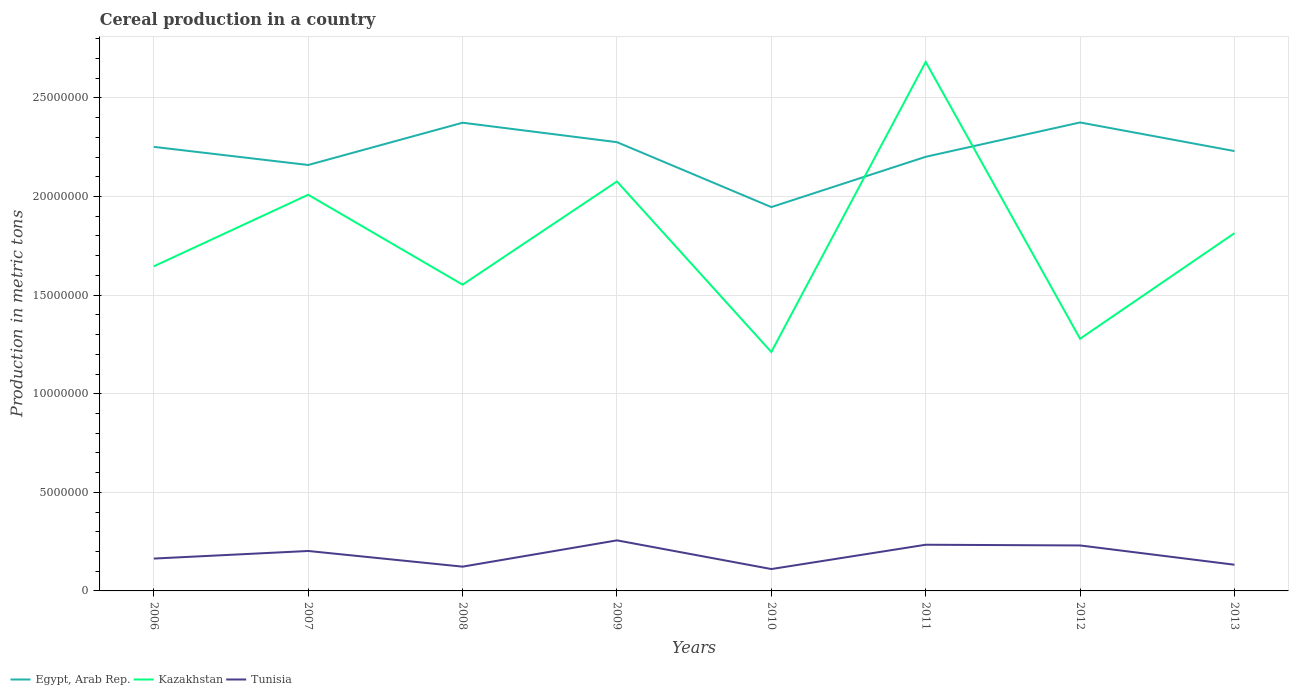Across all years, what is the maximum total cereal production in Egypt, Arab Rep.?
Ensure brevity in your answer.  1.95e+07. What is the total total cereal production in Tunisia in the graph?
Your answer should be very brief. -5.38e+05. What is the difference between the highest and the second highest total cereal production in Kazakhstan?
Offer a very short reply. 1.47e+07. Does the graph contain grids?
Your answer should be very brief. Yes. Where does the legend appear in the graph?
Your answer should be compact. Bottom left. How many legend labels are there?
Offer a terse response. 3. How are the legend labels stacked?
Your answer should be compact. Horizontal. What is the title of the graph?
Keep it short and to the point. Cereal production in a country. Does "Turkey" appear as one of the legend labels in the graph?
Offer a terse response. No. What is the label or title of the Y-axis?
Your answer should be very brief. Production in metric tons. What is the Production in metric tons of Egypt, Arab Rep. in 2006?
Offer a terse response. 2.25e+07. What is the Production in metric tons of Kazakhstan in 2006?
Offer a very short reply. 1.65e+07. What is the Production in metric tons of Tunisia in 2006?
Offer a very short reply. 1.64e+06. What is the Production in metric tons of Egypt, Arab Rep. in 2007?
Provide a short and direct response. 2.16e+07. What is the Production in metric tons in Kazakhstan in 2007?
Make the answer very short. 2.01e+07. What is the Production in metric tons of Tunisia in 2007?
Ensure brevity in your answer.  2.03e+06. What is the Production in metric tons of Egypt, Arab Rep. in 2008?
Your response must be concise. 2.37e+07. What is the Production in metric tons of Kazakhstan in 2008?
Your answer should be very brief. 1.55e+07. What is the Production in metric tons in Tunisia in 2008?
Your answer should be very brief. 1.23e+06. What is the Production in metric tons of Egypt, Arab Rep. in 2009?
Offer a very short reply. 2.28e+07. What is the Production in metric tons in Kazakhstan in 2009?
Ensure brevity in your answer.  2.08e+07. What is the Production in metric tons of Tunisia in 2009?
Make the answer very short. 2.56e+06. What is the Production in metric tons of Egypt, Arab Rep. in 2010?
Keep it short and to the point. 1.95e+07. What is the Production in metric tons of Kazakhstan in 2010?
Keep it short and to the point. 1.21e+07. What is the Production in metric tons of Tunisia in 2010?
Your response must be concise. 1.11e+06. What is the Production in metric tons of Egypt, Arab Rep. in 2011?
Make the answer very short. 2.20e+07. What is the Production in metric tons of Kazakhstan in 2011?
Ensure brevity in your answer.  2.68e+07. What is the Production in metric tons in Tunisia in 2011?
Keep it short and to the point. 2.34e+06. What is the Production in metric tons in Egypt, Arab Rep. in 2012?
Your response must be concise. 2.38e+07. What is the Production in metric tons of Kazakhstan in 2012?
Make the answer very short. 1.28e+07. What is the Production in metric tons in Tunisia in 2012?
Ensure brevity in your answer.  2.31e+06. What is the Production in metric tons in Egypt, Arab Rep. in 2013?
Provide a succinct answer. 2.23e+07. What is the Production in metric tons of Kazakhstan in 2013?
Give a very brief answer. 1.81e+07. What is the Production in metric tons in Tunisia in 2013?
Provide a succinct answer. 1.33e+06. Across all years, what is the maximum Production in metric tons in Egypt, Arab Rep.?
Ensure brevity in your answer.  2.38e+07. Across all years, what is the maximum Production in metric tons of Kazakhstan?
Ensure brevity in your answer.  2.68e+07. Across all years, what is the maximum Production in metric tons in Tunisia?
Make the answer very short. 2.56e+06. Across all years, what is the minimum Production in metric tons in Egypt, Arab Rep.?
Give a very brief answer. 1.95e+07. Across all years, what is the minimum Production in metric tons of Kazakhstan?
Ensure brevity in your answer.  1.21e+07. Across all years, what is the minimum Production in metric tons in Tunisia?
Your answer should be very brief. 1.11e+06. What is the total Production in metric tons of Egypt, Arab Rep. in the graph?
Ensure brevity in your answer.  1.78e+08. What is the total Production in metric tons in Kazakhstan in the graph?
Your answer should be compact. 1.43e+08. What is the total Production in metric tons in Tunisia in the graph?
Your answer should be compact. 1.45e+07. What is the difference between the Production in metric tons in Egypt, Arab Rep. in 2006 and that in 2007?
Ensure brevity in your answer.  9.19e+05. What is the difference between the Production in metric tons of Kazakhstan in 2006 and that in 2007?
Keep it short and to the point. -3.63e+06. What is the difference between the Production in metric tons of Tunisia in 2006 and that in 2007?
Your answer should be compact. -3.85e+05. What is the difference between the Production in metric tons of Egypt, Arab Rep. in 2006 and that in 2008?
Keep it short and to the point. -1.22e+06. What is the difference between the Production in metric tons in Kazakhstan in 2006 and that in 2008?
Your response must be concise. 9.31e+05. What is the difference between the Production in metric tons in Tunisia in 2006 and that in 2008?
Your response must be concise. 4.10e+05. What is the difference between the Production in metric tons in Egypt, Arab Rep. in 2006 and that in 2009?
Your answer should be compact. -2.38e+05. What is the difference between the Production in metric tons of Kazakhstan in 2006 and that in 2009?
Your answer should be compact. -4.30e+06. What is the difference between the Production in metric tons of Tunisia in 2006 and that in 2009?
Your answer should be compact. -9.23e+05. What is the difference between the Production in metric tons in Egypt, Arab Rep. in 2006 and that in 2010?
Your response must be concise. 3.05e+06. What is the difference between the Production in metric tons in Kazakhstan in 2006 and that in 2010?
Ensure brevity in your answer.  4.35e+06. What is the difference between the Production in metric tons of Tunisia in 2006 and that in 2010?
Keep it short and to the point. 5.31e+05. What is the difference between the Production in metric tons of Egypt, Arab Rep. in 2006 and that in 2011?
Your response must be concise. 5.04e+05. What is the difference between the Production in metric tons in Kazakhstan in 2006 and that in 2011?
Ensure brevity in your answer.  -1.04e+07. What is the difference between the Production in metric tons in Tunisia in 2006 and that in 2011?
Provide a short and direct response. -7.01e+05. What is the difference between the Production in metric tons in Egypt, Arab Rep. in 2006 and that in 2012?
Keep it short and to the point. -1.24e+06. What is the difference between the Production in metric tons in Kazakhstan in 2006 and that in 2012?
Offer a terse response. 3.67e+06. What is the difference between the Production in metric tons of Tunisia in 2006 and that in 2012?
Offer a terse response. -6.65e+05. What is the difference between the Production in metric tons of Egypt, Arab Rep. in 2006 and that in 2013?
Give a very brief answer. 2.13e+05. What is the difference between the Production in metric tons in Kazakhstan in 2006 and that in 2013?
Ensure brevity in your answer.  -1.68e+06. What is the difference between the Production in metric tons in Tunisia in 2006 and that in 2013?
Your answer should be very brief. 3.13e+05. What is the difference between the Production in metric tons of Egypt, Arab Rep. in 2007 and that in 2008?
Your response must be concise. -2.14e+06. What is the difference between the Production in metric tons of Kazakhstan in 2007 and that in 2008?
Your response must be concise. 4.56e+06. What is the difference between the Production in metric tons in Tunisia in 2007 and that in 2008?
Give a very brief answer. 7.95e+05. What is the difference between the Production in metric tons of Egypt, Arab Rep. in 2007 and that in 2009?
Keep it short and to the point. -1.16e+06. What is the difference between the Production in metric tons in Kazakhstan in 2007 and that in 2009?
Ensure brevity in your answer.  -6.74e+05. What is the difference between the Production in metric tons of Tunisia in 2007 and that in 2009?
Ensure brevity in your answer.  -5.38e+05. What is the difference between the Production in metric tons in Egypt, Arab Rep. in 2007 and that in 2010?
Your response must be concise. 2.13e+06. What is the difference between the Production in metric tons of Kazakhstan in 2007 and that in 2010?
Give a very brief answer. 7.97e+06. What is the difference between the Production in metric tons of Tunisia in 2007 and that in 2010?
Offer a very short reply. 9.16e+05. What is the difference between the Production in metric tons in Egypt, Arab Rep. in 2007 and that in 2011?
Keep it short and to the point. -4.16e+05. What is the difference between the Production in metric tons of Kazakhstan in 2007 and that in 2011?
Offer a very short reply. -6.74e+06. What is the difference between the Production in metric tons in Tunisia in 2007 and that in 2011?
Ensure brevity in your answer.  -3.17e+05. What is the difference between the Production in metric tons in Egypt, Arab Rep. in 2007 and that in 2012?
Give a very brief answer. -2.16e+06. What is the difference between the Production in metric tons in Kazakhstan in 2007 and that in 2012?
Your answer should be very brief. 7.30e+06. What is the difference between the Production in metric tons in Tunisia in 2007 and that in 2012?
Offer a terse response. -2.80e+05. What is the difference between the Production in metric tons of Egypt, Arab Rep. in 2007 and that in 2013?
Provide a succinct answer. -7.06e+05. What is the difference between the Production in metric tons in Kazakhstan in 2007 and that in 2013?
Your answer should be compact. 1.95e+06. What is the difference between the Production in metric tons in Tunisia in 2007 and that in 2013?
Provide a succinct answer. 6.98e+05. What is the difference between the Production in metric tons in Egypt, Arab Rep. in 2008 and that in 2009?
Keep it short and to the point. 9.86e+05. What is the difference between the Production in metric tons in Kazakhstan in 2008 and that in 2009?
Your response must be concise. -5.23e+06. What is the difference between the Production in metric tons of Tunisia in 2008 and that in 2009?
Your response must be concise. -1.33e+06. What is the difference between the Production in metric tons of Egypt, Arab Rep. in 2008 and that in 2010?
Give a very brief answer. 4.28e+06. What is the difference between the Production in metric tons of Kazakhstan in 2008 and that in 2010?
Provide a short and direct response. 3.41e+06. What is the difference between the Production in metric tons in Tunisia in 2008 and that in 2010?
Ensure brevity in your answer.  1.21e+05. What is the difference between the Production in metric tons of Egypt, Arab Rep. in 2008 and that in 2011?
Provide a short and direct response. 1.73e+06. What is the difference between the Production in metric tons of Kazakhstan in 2008 and that in 2011?
Your answer should be compact. -1.13e+07. What is the difference between the Production in metric tons of Tunisia in 2008 and that in 2011?
Make the answer very short. -1.11e+06. What is the difference between the Production in metric tons of Egypt, Arab Rep. in 2008 and that in 2012?
Provide a short and direct response. -1.27e+04. What is the difference between the Production in metric tons in Kazakhstan in 2008 and that in 2012?
Your answer should be very brief. 2.74e+06. What is the difference between the Production in metric tons of Tunisia in 2008 and that in 2012?
Make the answer very short. -1.07e+06. What is the difference between the Production in metric tons of Egypt, Arab Rep. in 2008 and that in 2013?
Offer a very short reply. 1.44e+06. What is the difference between the Production in metric tons in Kazakhstan in 2008 and that in 2013?
Your response must be concise. -2.61e+06. What is the difference between the Production in metric tons of Tunisia in 2008 and that in 2013?
Provide a short and direct response. -9.71e+04. What is the difference between the Production in metric tons of Egypt, Arab Rep. in 2009 and that in 2010?
Ensure brevity in your answer.  3.29e+06. What is the difference between the Production in metric tons in Kazakhstan in 2009 and that in 2010?
Offer a terse response. 8.65e+06. What is the difference between the Production in metric tons of Tunisia in 2009 and that in 2010?
Give a very brief answer. 1.45e+06. What is the difference between the Production in metric tons in Egypt, Arab Rep. in 2009 and that in 2011?
Your answer should be compact. 7.42e+05. What is the difference between the Production in metric tons of Kazakhstan in 2009 and that in 2011?
Provide a succinct answer. -6.06e+06. What is the difference between the Production in metric tons of Tunisia in 2009 and that in 2011?
Your answer should be compact. 2.22e+05. What is the difference between the Production in metric tons in Egypt, Arab Rep. in 2009 and that in 2012?
Make the answer very short. -9.99e+05. What is the difference between the Production in metric tons in Kazakhstan in 2009 and that in 2012?
Offer a very short reply. 7.98e+06. What is the difference between the Production in metric tons in Tunisia in 2009 and that in 2012?
Ensure brevity in your answer.  2.58e+05. What is the difference between the Production in metric tons in Egypt, Arab Rep. in 2009 and that in 2013?
Offer a very short reply. 4.52e+05. What is the difference between the Production in metric tons of Kazakhstan in 2009 and that in 2013?
Keep it short and to the point. 2.62e+06. What is the difference between the Production in metric tons of Tunisia in 2009 and that in 2013?
Offer a very short reply. 1.24e+06. What is the difference between the Production in metric tons in Egypt, Arab Rep. in 2010 and that in 2011?
Your answer should be compact. -2.55e+06. What is the difference between the Production in metric tons in Kazakhstan in 2010 and that in 2011?
Give a very brief answer. -1.47e+07. What is the difference between the Production in metric tons in Tunisia in 2010 and that in 2011?
Offer a very short reply. -1.23e+06. What is the difference between the Production in metric tons in Egypt, Arab Rep. in 2010 and that in 2012?
Provide a succinct answer. -4.29e+06. What is the difference between the Production in metric tons of Kazakhstan in 2010 and that in 2012?
Make the answer very short. -6.72e+05. What is the difference between the Production in metric tons in Tunisia in 2010 and that in 2012?
Your response must be concise. -1.20e+06. What is the difference between the Production in metric tons in Egypt, Arab Rep. in 2010 and that in 2013?
Offer a very short reply. -2.84e+06. What is the difference between the Production in metric tons in Kazakhstan in 2010 and that in 2013?
Your answer should be very brief. -6.03e+06. What is the difference between the Production in metric tons in Tunisia in 2010 and that in 2013?
Keep it short and to the point. -2.19e+05. What is the difference between the Production in metric tons in Egypt, Arab Rep. in 2011 and that in 2012?
Your answer should be very brief. -1.74e+06. What is the difference between the Production in metric tons of Kazakhstan in 2011 and that in 2012?
Make the answer very short. 1.40e+07. What is the difference between the Production in metric tons of Tunisia in 2011 and that in 2012?
Your answer should be compact. 3.61e+04. What is the difference between the Production in metric tons in Egypt, Arab Rep. in 2011 and that in 2013?
Make the answer very short. -2.90e+05. What is the difference between the Production in metric tons of Kazakhstan in 2011 and that in 2013?
Offer a terse response. 8.68e+06. What is the difference between the Production in metric tons of Tunisia in 2011 and that in 2013?
Your answer should be compact. 1.01e+06. What is the difference between the Production in metric tons of Egypt, Arab Rep. in 2012 and that in 2013?
Your answer should be very brief. 1.45e+06. What is the difference between the Production in metric tons in Kazakhstan in 2012 and that in 2013?
Offer a terse response. -5.35e+06. What is the difference between the Production in metric tons in Tunisia in 2012 and that in 2013?
Provide a short and direct response. 9.78e+05. What is the difference between the Production in metric tons of Egypt, Arab Rep. in 2006 and the Production in metric tons of Kazakhstan in 2007?
Ensure brevity in your answer.  2.43e+06. What is the difference between the Production in metric tons in Egypt, Arab Rep. in 2006 and the Production in metric tons in Tunisia in 2007?
Offer a terse response. 2.05e+07. What is the difference between the Production in metric tons in Kazakhstan in 2006 and the Production in metric tons in Tunisia in 2007?
Keep it short and to the point. 1.44e+07. What is the difference between the Production in metric tons in Egypt, Arab Rep. in 2006 and the Production in metric tons in Kazakhstan in 2008?
Your answer should be very brief. 6.99e+06. What is the difference between the Production in metric tons of Egypt, Arab Rep. in 2006 and the Production in metric tons of Tunisia in 2008?
Ensure brevity in your answer.  2.13e+07. What is the difference between the Production in metric tons in Kazakhstan in 2006 and the Production in metric tons in Tunisia in 2008?
Offer a terse response. 1.52e+07. What is the difference between the Production in metric tons of Egypt, Arab Rep. in 2006 and the Production in metric tons of Kazakhstan in 2009?
Keep it short and to the point. 1.75e+06. What is the difference between the Production in metric tons in Egypt, Arab Rep. in 2006 and the Production in metric tons in Tunisia in 2009?
Offer a terse response. 2.00e+07. What is the difference between the Production in metric tons of Kazakhstan in 2006 and the Production in metric tons of Tunisia in 2009?
Offer a very short reply. 1.39e+07. What is the difference between the Production in metric tons in Egypt, Arab Rep. in 2006 and the Production in metric tons in Kazakhstan in 2010?
Your response must be concise. 1.04e+07. What is the difference between the Production in metric tons of Egypt, Arab Rep. in 2006 and the Production in metric tons of Tunisia in 2010?
Provide a short and direct response. 2.14e+07. What is the difference between the Production in metric tons in Kazakhstan in 2006 and the Production in metric tons in Tunisia in 2010?
Ensure brevity in your answer.  1.54e+07. What is the difference between the Production in metric tons of Egypt, Arab Rep. in 2006 and the Production in metric tons of Kazakhstan in 2011?
Keep it short and to the point. -4.31e+06. What is the difference between the Production in metric tons of Egypt, Arab Rep. in 2006 and the Production in metric tons of Tunisia in 2011?
Provide a succinct answer. 2.02e+07. What is the difference between the Production in metric tons in Kazakhstan in 2006 and the Production in metric tons in Tunisia in 2011?
Offer a very short reply. 1.41e+07. What is the difference between the Production in metric tons of Egypt, Arab Rep. in 2006 and the Production in metric tons of Kazakhstan in 2012?
Make the answer very short. 9.73e+06. What is the difference between the Production in metric tons of Egypt, Arab Rep. in 2006 and the Production in metric tons of Tunisia in 2012?
Keep it short and to the point. 2.02e+07. What is the difference between the Production in metric tons of Kazakhstan in 2006 and the Production in metric tons of Tunisia in 2012?
Offer a very short reply. 1.42e+07. What is the difference between the Production in metric tons in Egypt, Arab Rep. in 2006 and the Production in metric tons in Kazakhstan in 2013?
Ensure brevity in your answer.  4.38e+06. What is the difference between the Production in metric tons in Egypt, Arab Rep. in 2006 and the Production in metric tons in Tunisia in 2013?
Ensure brevity in your answer.  2.12e+07. What is the difference between the Production in metric tons in Kazakhstan in 2006 and the Production in metric tons in Tunisia in 2013?
Make the answer very short. 1.51e+07. What is the difference between the Production in metric tons of Egypt, Arab Rep. in 2007 and the Production in metric tons of Kazakhstan in 2008?
Ensure brevity in your answer.  6.07e+06. What is the difference between the Production in metric tons in Egypt, Arab Rep. in 2007 and the Production in metric tons in Tunisia in 2008?
Make the answer very short. 2.04e+07. What is the difference between the Production in metric tons of Kazakhstan in 2007 and the Production in metric tons of Tunisia in 2008?
Give a very brief answer. 1.89e+07. What is the difference between the Production in metric tons in Egypt, Arab Rep. in 2007 and the Production in metric tons in Kazakhstan in 2009?
Offer a very short reply. 8.35e+05. What is the difference between the Production in metric tons of Egypt, Arab Rep. in 2007 and the Production in metric tons of Tunisia in 2009?
Offer a terse response. 1.90e+07. What is the difference between the Production in metric tons in Kazakhstan in 2007 and the Production in metric tons in Tunisia in 2009?
Your answer should be compact. 1.75e+07. What is the difference between the Production in metric tons of Egypt, Arab Rep. in 2007 and the Production in metric tons of Kazakhstan in 2010?
Make the answer very short. 9.48e+06. What is the difference between the Production in metric tons in Egypt, Arab Rep. in 2007 and the Production in metric tons in Tunisia in 2010?
Give a very brief answer. 2.05e+07. What is the difference between the Production in metric tons of Kazakhstan in 2007 and the Production in metric tons of Tunisia in 2010?
Ensure brevity in your answer.  1.90e+07. What is the difference between the Production in metric tons in Egypt, Arab Rep. in 2007 and the Production in metric tons in Kazakhstan in 2011?
Offer a very short reply. -5.23e+06. What is the difference between the Production in metric tons in Egypt, Arab Rep. in 2007 and the Production in metric tons in Tunisia in 2011?
Offer a terse response. 1.93e+07. What is the difference between the Production in metric tons in Kazakhstan in 2007 and the Production in metric tons in Tunisia in 2011?
Your answer should be very brief. 1.77e+07. What is the difference between the Production in metric tons of Egypt, Arab Rep. in 2007 and the Production in metric tons of Kazakhstan in 2012?
Your answer should be compact. 8.81e+06. What is the difference between the Production in metric tons of Egypt, Arab Rep. in 2007 and the Production in metric tons of Tunisia in 2012?
Your answer should be compact. 1.93e+07. What is the difference between the Production in metric tons in Kazakhstan in 2007 and the Production in metric tons in Tunisia in 2012?
Provide a succinct answer. 1.78e+07. What is the difference between the Production in metric tons of Egypt, Arab Rep. in 2007 and the Production in metric tons of Kazakhstan in 2013?
Provide a succinct answer. 3.46e+06. What is the difference between the Production in metric tons of Egypt, Arab Rep. in 2007 and the Production in metric tons of Tunisia in 2013?
Provide a succinct answer. 2.03e+07. What is the difference between the Production in metric tons of Kazakhstan in 2007 and the Production in metric tons of Tunisia in 2013?
Provide a succinct answer. 1.88e+07. What is the difference between the Production in metric tons in Egypt, Arab Rep. in 2008 and the Production in metric tons in Kazakhstan in 2009?
Keep it short and to the point. 2.98e+06. What is the difference between the Production in metric tons of Egypt, Arab Rep. in 2008 and the Production in metric tons of Tunisia in 2009?
Provide a succinct answer. 2.12e+07. What is the difference between the Production in metric tons in Kazakhstan in 2008 and the Production in metric tons in Tunisia in 2009?
Give a very brief answer. 1.30e+07. What is the difference between the Production in metric tons of Egypt, Arab Rep. in 2008 and the Production in metric tons of Kazakhstan in 2010?
Offer a very short reply. 1.16e+07. What is the difference between the Production in metric tons in Egypt, Arab Rep. in 2008 and the Production in metric tons in Tunisia in 2010?
Your answer should be compact. 2.26e+07. What is the difference between the Production in metric tons of Kazakhstan in 2008 and the Production in metric tons of Tunisia in 2010?
Your response must be concise. 1.44e+07. What is the difference between the Production in metric tons of Egypt, Arab Rep. in 2008 and the Production in metric tons of Kazakhstan in 2011?
Give a very brief answer. -3.08e+06. What is the difference between the Production in metric tons of Egypt, Arab Rep. in 2008 and the Production in metric tons of Tunisia in 2011?
Provide a succinct answer. 2.14e+07. What is the difference between the Production in metric tons of Kazakhstan in 2008 and the Production in metric tons of Tunisia in 2011?
Provide a succinct answer. 1.32e+07. What is the difference between the Production in metric tons in Egypt, Arab Rep. in 2008 and the Production in metric tons in Kazakhstan in 2012?
Offer a terse response. 1.10e+07. What is the difference between the Production in metric tons in Egypt, Arab Rep. in 2008 and the Production in metric tons in Tunisia in 2012?
Keep it short and to the point. 2.14e+07. What is the difference between the Production in metric tons of Kazakhstan in 2008 and the Production in metric tons of Tunisia in 2012?
Ensure brevity in your answer.  1.32e+07. What is the difference between the Production in metric tons of Egypt, Arab Rep. in 2008 and the Production in metric tons of Kazakhstan in 2013?
Your answer should be compact. 5.60e+06. What is the difference between the Production in metric tons in Egypt, Arab Rep. in 2008 and the Production in metric tons in Tunisia in 2013?
Offer a very short reply. 2.24e+07. What is the difference between the Production in metric tons in Kazakhstan in 2008 and the Production in metric tons in Tunisia in 2013?
Your answer should be compact. 1.42e+07. What is the difference between the Production in metric tons in Egypt, Arab Rep. in 2009 and the Production in metric tons in Kazakhstan in 2010?
Make the answer very short. 1.06e+07. What is the difference between the Production in metric tons in Egypt, Arab Rep. in 2009 and the Production in metric tons in Tunisia in 2010?
Make the answer very short. 2.16e+07. What is the difference between the Production in metric tons in Kazakhstan in 2009 and the Production in metric tons in Tunisia in 2010?
Provide a succinct answer. 1.97e+07. What is the difference between the Production in metric tons in Egypt, Arab Rep. in 2009 and the Production in metric tons in Kazakhstan in 2011?
Keep it short and to the point. -4.07e+06. What is the difference between the Production in metric tons of Egypt, Arab Rep. in 2009 and the Production in metric tons of Tunisia in 2011?
Make the answer very short. 2.04e+07. What is the difference between the Production in metric tons in Kazakhstan in 2009 and the Production in metric tons in Tunisia in 2011?
Keep it short and to the point. 1.84e+07. What is the difference between the Production in metric tons in Egypt, Arab Rep. in 2009 and the Production in metric tons in Kazakhstan in 2012?
Provide a short and direct response. 9.97e+06. What is the difference between the Production in metric tons in Egypt, Arab Rep. in 2009 and the Production in metric tons in Tunisia in 2012?
Offer a very short reply. 2.05e+07. What is the difference between the Production in metric tons of Kazakhstan in 2009 and the Production in metric tons of Tunisia in 2012?
Make the answer very short. 1.85e+07. What is the difference between the Production in metric tons of Egypt, Arab Rep. in 2009 and the Production in metric tons of Kazakhstan in 2013?
Your answer should be compact. 4.62e+06. What is the difference between the Production in metric tons in Egypt, Arab Rep. in 2009 and the Production in metric tons in Tunisia in 2013?
Give a very brief answer. 2.14e+07. What is the difference between the Production in metric tons of Kazakhstan in 2009 and the Production in metric tons of Tunisia in 2013?
Give a very brief answer. 1.94e+07. What is the difference between the Production in metric tons in Egypt, Arab Rep. in 2010 and the Production in metric tons in Kazakhstan in 2011?
Your answer should be very brief. -7.36e+06. What is the difference between the Production in metric tons in Egypt, Arab Rep. in 2010 and the Production in metric tons in Tunisia in 2011?
Provide a short and direct response. 1.71e+07. What is the difference between the Production in metric tons of Kazakhstan in 2010 and the Production in metric tons of Tunisia in 2011?
Give a very brief answer. 9.77e+06. What is the difference between the Production in metric tons in Egypt, Arab Rep. in 2010 and the Production in metric tons in Kazakhstan in 2012?
Give a very brief answer. 6.68e+06. What is the difference between the Production in metric tons of Egypt, Arab Rep. in 2010 and the Production in metric tons of Tunisia in 2012?
Offer a very short reply. 1.72e+07. What is the difference between the Production in metric tons in Kazakhstan in 2010 and the Production in metric tons in Tunisia in 2012?
Provide a succinct answer. 9.81e+06. What is the difference between the Production in metric tons in Egypt, Arab Rep. in 2010 and the Production in metric tons in Kazakhstan in 2013?
Your answer should be compact. 1.32e+06. What is the difference between the Production in metric tons in Egypt, Arab Rep. in 2010 and the Production in metric tons in Tunisia in 2013?
Provide a succinct answer. 1.81e+07. What is the difference between the Production in metric tons of Kazakhstan in 2010 and the Production in metric tons of Tunisia in 2013?
Give a very brief answer. 1.08e+07. What is the difference between the Production in metric tons of Egypt, Arab Rep. in 2011 and the Production in metric tons of Kazakhstan in 2012?
Your answer should be compact. 9.23e+06. What is the difference between the Production in metric tons of Egypt, Arab Rep. in 2011 and the Production in metric tons of Tunisia in 2012?
Your response must be concise. 1.97e+07. What is the difference between the Production in metric tons in Kazakhstan in 2011 and the Production in metric tons in Tunisia in 2012?
Offer a very short reply. 2.45e+07. What is the difference between the Production in metric tons of Egypt, Arab Rep. in 2011 and the Production in metric tons of Kazakhstan in 2013?
Keep it short and to the point. 3.87e+06. What is the difference between the Production in metric tons of Egypt, Arab Rep. in 2011 and the Production in metric tons of Tunisia in 2013?
Give a very brief answer. 2.07e+07. What is the difference between the Production in metric tons in Kazakhstan in 2011 and the Production in metric tons in Tunisia in 2013?
Offer a terse response. 2.55e+07. What is the difference between the Production in metric tons in Egypt, Arab Rep. in 2012 and the Production in metric tons in Kazakhstan in 2013?
Offer a terse response. 5.61e+06. What is the difference between the Production in metric tons in Egypt, Arab Rep. in 2012 and the Production in metric tons in Tunisia in 2013?
Keep it short and to the point. 2.24e+07. What is the difference between the Production in metric tons in Kazakhstan in 2012 and the Production in metric tons in Tunisia in 2013?
Offer a terse response. 1.15e+07. What is the average Production in metric tons of Egypt, Arab Rep. per year?
Provide a short and direct response. 2.23e+07. What is the average Production in metric tons in Kazakhstan per year?
Offer a very short reply. 1.78e+07. What is the average Production in metric tons of Tunisia per year?
Ensure brevity in your answer.  1.82e+06. In the year 2006, what is the difference between the Production in metric tons in Egypt, Arab Rep. and Production in metric tons in Kazakhstan?
Offer a very short reply. 6.06e+06. In the year 2006, what is the difference between the Production in metric tons of Egypt, Arab Rep. and Production in metric tons of Tunisia?
Keep it short and to the point. 2.09e+07. In the year 2006, what is the difference between the Production in metric tons in Kazakhstan and Production in metric tons in Tunisia?
Provide a succinct answer. 1.48e+07. In the year 2007, what is the difference between the Production in metric tons in Egypt, Arab Rep. and Production in metric tons in Kazakhstan?
Ensure brevity in your answer.  1.51e+06. In the year 2007, what is the difference between the Production in metric tons of Egypt, Arab Rep. and Production in metric tons of Tunisia?
Make the answer very short. 1.96e+07. In the year 2007, what is the difference between the Production in metric tons in Kazakhstan and Production in metric tons in Tunisia?
Your answer should be compact. 1.81e+07. In the year 2008, what is the difference between the Production in metric tons of Egypt, Arab Rep. and Production in metric tons of Kazakhstan?
Your answer should be very brief. 8.21e+06. In the year 2008, what is the difference between the Production in metric tons of Egypt, Arab Rep. and Production in metric tons of Tunisia?
Provide a succinct answer. 2.25e+07. In the year 2008, what is the difference between the Production in metric tons of Kazakhstan and Production in metric tons of Tunisia?
Provide a short and direct response. 1.43e+07. In the year 2009, what is the difference between the Production in metric tons in Egypt, Arab Rep. and Production in metric tons in Kazakhstan?
Ensure brevity in your answer.  1.99e+06. In the year 2009, what is the difference between the Production in metric tons in Egypt, Arab Rep. and Production in metric tons in Tunisia?
Your answer should be compact. 2.02e+07. In the year 2009, what is the difference between the Production in metric tons of Kazakhstan and Production in metric tons of Tunisia?
Provide a succinct answer. 1.82e+07. In the year 2010, what is the difference between the Production in metric tons in Egypt, Arab Rep. and Production in metric tons in Kazakhstan?
Your answer should be compact. 7.35e+06. In the year 2010, what is the difference between the Production in metric tons in Egypt, Arab Rep. and Production in metric tons in Tunisia?
Provide a short and direct response. 1.84e+07. In the year 2010, what is the difference between the Production in metric tons of Kazakhstan and Production in metric tons of Tunisia?
Your response must be concise. 1.10e+07. In the year 2011, what is the difference between the Production in metric tons of Egypt, Arab Rep. and Production in metric tons of Kazakhstan?
Keep it short and to the point. -4.81e+06. In the year 2011, what is the difference between the Production in metric tons in Egypt, Arab Rep. and Production in metric tons in Tunisia?
Your answer should be compact. 1.97e+07. In the year 2011, what is the difference between the Production in metric tons in Kazakhstan and Production in metric tons in Tunisia?
Make the answer very short. 2.45e+07. In the year 2012, what is the difference between the Production in metric tons in Egypt, Arab Rep. and Production in metric tons in Kazakhstan?
Give a very brief answer. 1.10e+07. In the year 2012, what is the difference between the Production in metric tons in Egypt, Arab Rep. and Production in metric tons in Tunisia?
Provide a succinct answer. 2.14e+07. In the year 2012, what is the difference between the Production in metric tons of Kazakhstan and Production in metric tons of Tunisia?
Offer a very short reply. 1.05e+07. In the year 2013, what is the difference between the Production in metric tons of Egypt, Arab Rep. and Production in metric tons of Kazakhstan?
Give a very brief answer. 4.16e+06. In the year 2013, what is the difference between the Production in metric tons in Egypt, Arab Rep. and Production in metric tons in Tunisia?
Provide a short and direct response. 2.10e+07. In the year 2013, what is the difference between the Production in metric tons in Kazakhstan and Production in metric tons in Tunisia?
Offer a very short reply. 1.68e+07. What is the ratio of the Production in metric tons in Egypt, Arab Rep. in 2006 to that in 2007?
Your answer should be very brief. 1.04. What is the ratio of the Production in metric tons of Kazakhstan in 2006 to that in 2007?
Make the answer very short. 0.82. What is the ratio of the Production in metric tons in Tunisia in 2006 to that in 2007?
Your answer should be compact. 0.81. What is the ratio of the Production in metric tons of Egypt, Arab Rep. in 2006 to that in 2008?
Ensure brevity in your answer.  0.95. What is the ratio of the Production in metric tons in Kazakhstan in 2006 to that in 2008?
Keep it short and to the point. 1.06. What is the ratio of the Production in metric tons of Tunisia in 2006 to that in 2008?
Provide a short and direct response. 1.33. What is the ratio of the Production in metric tons in Egypt, Arab Rep. in 2006 to that in 2009?
Offer a very short reply. 0.99. What is the ratio of the Production in metric tons of Kazakhstan in 2006 to that in 2009?
Keep it short and to the point. 0.79. What is the ratio of the Production in metric tons in Tunisia in 2006 to that in 2009?
Keep it short and to the point. 0.64. What is the ratio of the Production in metric tons of Egypt, Arab Rep. in 2006 to that in 2010?
Give a very brief answer. 1.16. What is the ratio of the Production in metric tons in Kazakhstan in 2006 to that in 2010?
Provide a short and direct response. 1.36. What is the ratio of the Production in metric tons of Tunisia in 2006 to that in 2010?
Provide a succinct answer. 1.48. What is the ratio of the Production in metric tons in Egypt, Arab Rep. in 2006 to that in 2011?
Offer a terse response. 1.02. What is the ratio of the Production in metric tons of Kazakhstan in 2006 to that in 2011?
Offer a very short reply. 0.61. What is the ratio of the Production in metric tons of Tunisia in 2006 to that in 2011?
Provide a succinct answer. 0.7. What is the ratio of the Production in metric tons in Egypt, Arab Rep. in 2006 to that in 2012?
Offer a terse response. 0.95. What is the ratio of the Production in metric tons in Kazakhstan in 2006 to that in 2012?
Your answer should be compact. 1.29. What is the ratio of the Production in metric tons in Tunisia in 2006 to that in 2012?
Keep it short and to the point. 0.71. What is the ratio of the Production in metric tons of Egypt, Arab Rep. in 2006 to that in 2013?
Your answer should be compact. 1.01. What is the ratio of the Production in metric tons in Kazakhstan in 2006 to that in 2013?
Provide a short and direct response. 0.91. What is the ratio of the Production in metric tons in Tunisia in 2006 to that in 2013?
Your answer should be compact. 1.24. What is the ratio of the Production in metric tons of Egypt, Arab Rep. in 2007 to that in 2008?
Ensure brevity in your answer.  0.91. What is the ratio of the Production in metric tons in Kazakhstan in 2007 to that in 2008?
Keep it short and to the point. 1.29. What is the ratio of the Production in metric tons in Tunisia in 2007 to that in 2008?
Provide a succinct answer. 1.65. What is the ratio of the Production in metric tons of Egypt, Arab Rep. in 2007 to that in 2009?
Ensure brevity in your answer.  0.95. What is the ratio of the Production in metric tons of Kazakhstan in 2007 to that in 2009?
Provide a succinct answer. 0.97. What is the ratio of the Production in metric tons in Tunisia in 2007 to that in 2009?
Your answer should be very brief. 0.79. What is the ratio of the Production in metric tons of Egypt, Arab Rep. in 2007 to that in 2010?
Ensure brevity in your answer.  1.11. What is the ratio of the Production in metric tons in Kazakhstan in 2007 to that in 2010?
Give a very brief answer. 1.66. What is the ratio of the Production in metric tons of Tunisia in 2007 to that in 2010?
Give a very brief answer. 1.83. What is the ratio of the Production in metric tons of Egypt, Arab Rep. in 2007 to that in 2011?
Ensure brevity in your answer.  0.98. What is the ratio of the Production in metric tons in Kazakhstan in 2007 to that in 2011?
Offer a terse response. 0.75. What is the ratio of the Production in metric tons in Tunisia in 2007 to that in 2011?
Make the answer very short. 0.86. What is the ratio of the Production in metric tons of Egypt, Arab Rep. in 2007 to that in 2012?
Give a very brief answer. 0.91. What is the ratio of the Production in metric tons of Kazakhstan in 2007 to that in 2012?
Your answer should be very brief. 1.57. What is the ratio of the Production in metric tons of Tunisia in 2007 to that in 2012?
Offer a terse response. 0.88. What is the ratio of the Production in metric tons in Egypt, Arab Rep. in 2007 to that in 2013?
Your answer should be very brief. 0.97. What is the ratio of the Production in metric tons in Kazakhstan in 2007 to that in 2013?
Keep it short and to the point. 1.11. What is the ratio of the Production in metric tons in Tunisia in 2007 to that in 2013?
Provide a short and direct response. 1.53. What is the ratio of the Production in metric tons in Egypt, Arab Rep. in 2008 to that in 2009?
Make the answer very short. 1.04. What is the ratio of the Production in metric tons of Kazakhstan in 2008 to that in 2009?
Give a very brief answer. 0.75. What is the ratio of the Production in metric tons of Tunisia in 2008 to that in 2009?
Make the answer very short. 0.48. What is the ratio of the Production in metric tons in Egypt, Arab Rep. in 2008 to that in 2010?
Your answer should be very brief. 1.22. What is the ratio of the Production in metric tons of Kazakhstan in 2008 to that in 2010?
Offer a terse response. 1.28. What is the ratio of the Production in metric tons of Tunisia in 2008 to that in 2010?
Your response must be concise. 1.11. What is the ratio of the Production in metric tons of Egypt, Arab Rep. in 2008 to that in 2011?
Provide a succinct answer. 1.08. What is the ratio of the Production in metric tons of Kazakhstan in 2008 to that in 2011?
Offer a very short reply. 0.58. What is the ratio of the Production in metric tons of Tunisia in 2008 to that in 2011?
Your response must be concise. 0.53. What is the ratio of the Production in metric tons in Egypt, Arab Rep. in 2008 to that in 2012?
Give a very brief answer. 1. What is the ratio of the Production in metric tons in Kazakhstan in 2008 to that in 2012?
Give a very brief answer. 1.21. What is the ratio of the Production in metric tons in Tunisia in 2008 to that in 2012?
Your response must be concise. 0.53. What is the ratio of the Production in metric tons in Egypt, Arab Rep. in 2008 to that in 2013?
Your answer should be very brief. 1.06. What is the ratio of the Production in metric tons of Kazakhstan in 2008 to that in 2013?
Keep it short and to the point. 0.86. What is the ratio of the Production in metric tons in Tunisia in 2008 to that in 2013?
Ensure brevity in your answer.  0.93. What is the ratio of the Production in metric tons in Egypt, Arab Rep. in 2009 to that in 2010?
Provide a succinct answer. 1.17. What is the ratio of the Production in metric tons of Kazakhstan in 2009 to that in 2010?
Offer a very short reply. 1.71. What is the ratio of the Production in metric tons of Tunisia in 2009 to that in 2010?
Your response must be concise. 2.31. What is the ratio of the Production in metric tons in Egypt, Arab Rep. in 2009 to that in 2011?
Your response must be concise. 1.03. What is the ratio of the Production in metric tons in Kazakhstan in 2009 to that in 2011?
Offer a very short reply. 0.77. What is the ratio of the Production in metric tons of Tunisia in 2009 to that in 2011?
Offer a terse response. 1.09. What is the ratio of the Production in metric tons of Egypt, Arab Rep. in 2009 to that in 2012?
Your answer should be compact. 0.96. What is the ratio of the Production in metric tons in Kazakhstan in 2009 to that in 2012?
Offer a very short reply. 1.62. What is the ratio of the Production in metric tons of Tunisia in 2009 to that in 2012?
Your answer should be compact. 1.11. What is the ratio of the Production in metric tons of Egypt, Arab Rep. in 2009 to that in 2013?
Make the answer very short. 1.02. What is the ratio of the Production in metric tons in Kazakhstan in 2009 to that in 2013?
Ensure brevity in your answer.  1.14. What is the ratio of the Production in metric tons in Tunisia in 2009 to that in 2013?
Provide a short and direct response. 1.93. What is the ratio of the Production in metric tons in Egypt, Arab Rep. in 2010 to that in 2011?
Offer a very short reply. 0.88. What is the ratio of the Production in metric tons in Kazakhstan in 2010 to that in 2011?
Make the answer very short. 0.45. What is the ratio of the Production in metric tons in Tunisia in 2010 to that in 2011?
Your response must be concise. 0.47. What is the ratio of the Production in metric tons in Egypt, Arab Rep. in 2010 to that in 2012?
Offer a terse response. 0.82. What is the ratio of the Production in metric tons of Kazakhstan in 2010 to that in 2012?
Ensure brevity in your answer.  0.95. What is the ratio of the Production in metric tons in Tunisia in 2010 to that in 2012?
Offer a terse response. 0.48. What is the ratio of the Production in metric tons of Egypt, Arab Rep. in 2010 to that in 2013?
Make the answer very short. 0.87. What is the ratio of the Production in metric tons of Kazakhstan in 2010 to that in 2013?
Ensure brevity in your answer.  0.67. What is the ratio of the Production in metric tons in Tunisia in 2010 to that in 2013?
Your answer should be very brief. 0.84. What is the ratio of the Production in metric tons of Egypt, Arab Rep. in 2011 to that in 2012?
Make the answer very short. 0.93. What is the ratio of the Production in metric tons in Kazakhstan in 2011 to that in 2012?
Provide a short and direct response. 2.1. What is the ratio of the Production in metric tons of Tunisia in 2011 to that in 2012?
Offer a terse response. 1.02. What is the ratio of the Production in metric tons of Egypt, Arab Rep. in 2011 to that in 2013?
Keep it short and to the point. 0.99. What is the ratio of the Production in metric tons of Kazakhstan in 2011 to that in 2013?
Your response must be concise. 1.48. What is the ratio of the Production in metric tons in Tunisia in 2011 to that in 2013?
Provide a succinct answer. 1.76. What is the ratio of the Production in metric tons of Egypt, Arab Rep. in 2012 to that in 2013?
Provide a succinct answer. 1.06. What is the ratio of the Production in metric tons in Kazakhstan in 2012 to that in 2013?
Provide a succinct answer. 0.7. What is the ratio of the Production in metric tons in Tunisia in 2012 to that in 2013?
Give a very brief answer. 1.74. What is the difference between the highest and the second highest Production in metric tons of Egypt, Arab Rep.?
Make the answer very short. 1.27e+04. What is the difference between the highest and the second highest Production in metric tons in Kazakhstan?
Give a very brief answer. 6.06e+06. What is the difference between the highest and the second highest Production in metric tons of Tunisia?
Your answer should be compact. 2.22e+05. What is the difference between the highest and the lowest Production in metric tons of Egypt, Arab Rep.?
Your response must be concise. 4.29e+06. What is the difference between the highest and the lowest Production in metric tons of Kazakhstan?
Provide a succinct answer. 1.47e+07. What is the difference between the highest and the lowest Production in metric tons in Tunisia?
Your answer should be compact. 1.45e+06. 